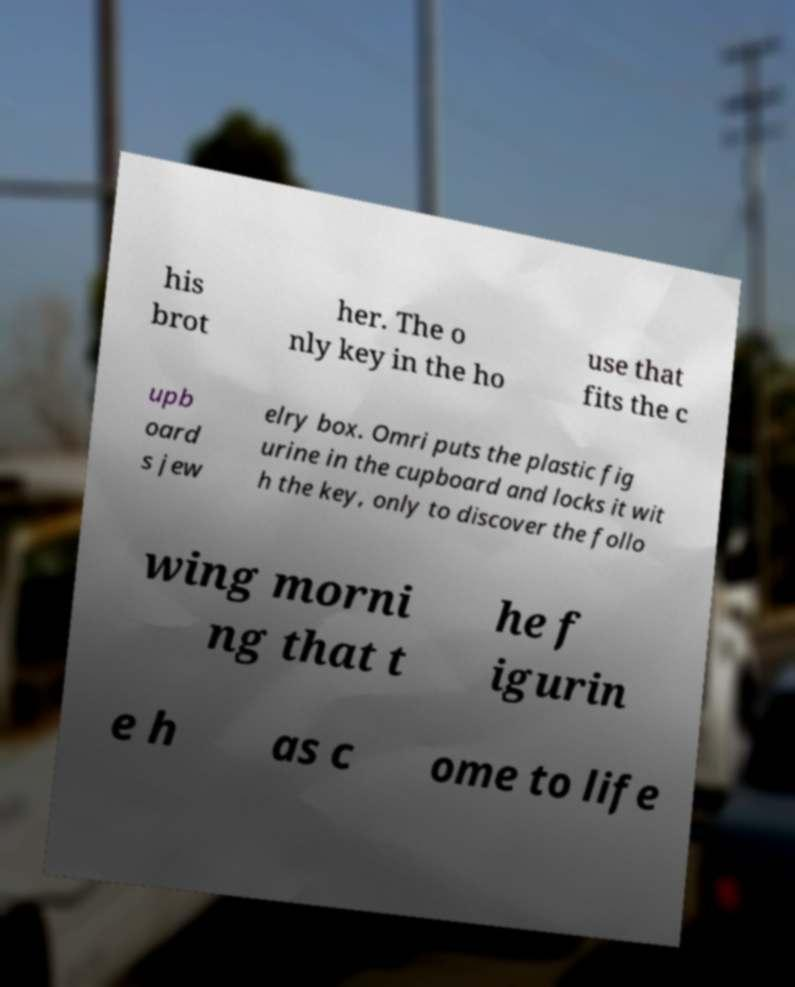Can you read and provide the text displayed in the image?This photo seems to have some interesting text. Can you extract and type it out for me? his brot her. The o nly key in the ho use that fits the c upb oard s jew elry box. Omri puts the plastic fig urine in the cupboard and locks it wit h the key, only to discover the follo wing morni ng that t he f igurin e h as c ome to life 